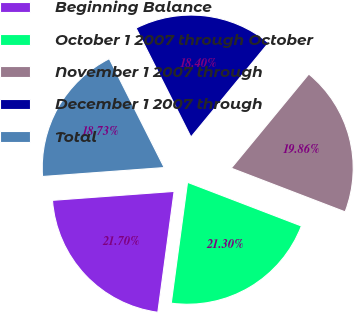Convert chart to OTSL. <chart><loc_0><loc_0><loc_500><loc_500><pie_chart><fcel>Beginning Balance<fcel>October 1 2007 through October<fcel>November 1 2007 through<fcel>December 1 2007 through<fcel>Total<nl><fcel>21.7%<fcel>21.3%<fcel>19.86%<fcel>18.4%<fcel>18.73%<nl></chart> 